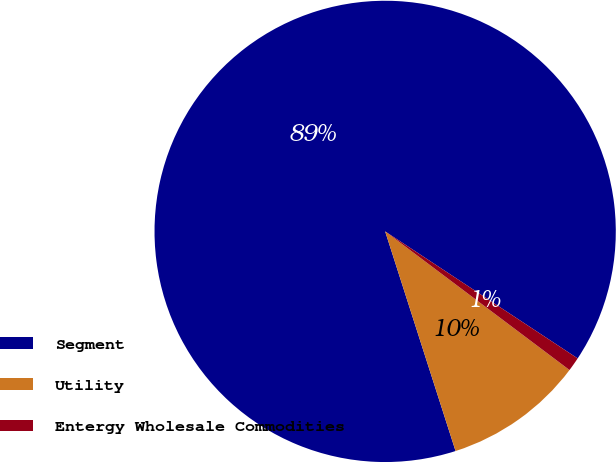Convert chart to OTSL. <chart><loc_0><loc_0><loc_500><loc_500><pie_chart><fcel>Segment<fcel>Utility<fcel>Entergy Wholesale Commodities<nl><fcel>89.22%<fcel>9.8%<fcel>0.98%<nl></chart> 